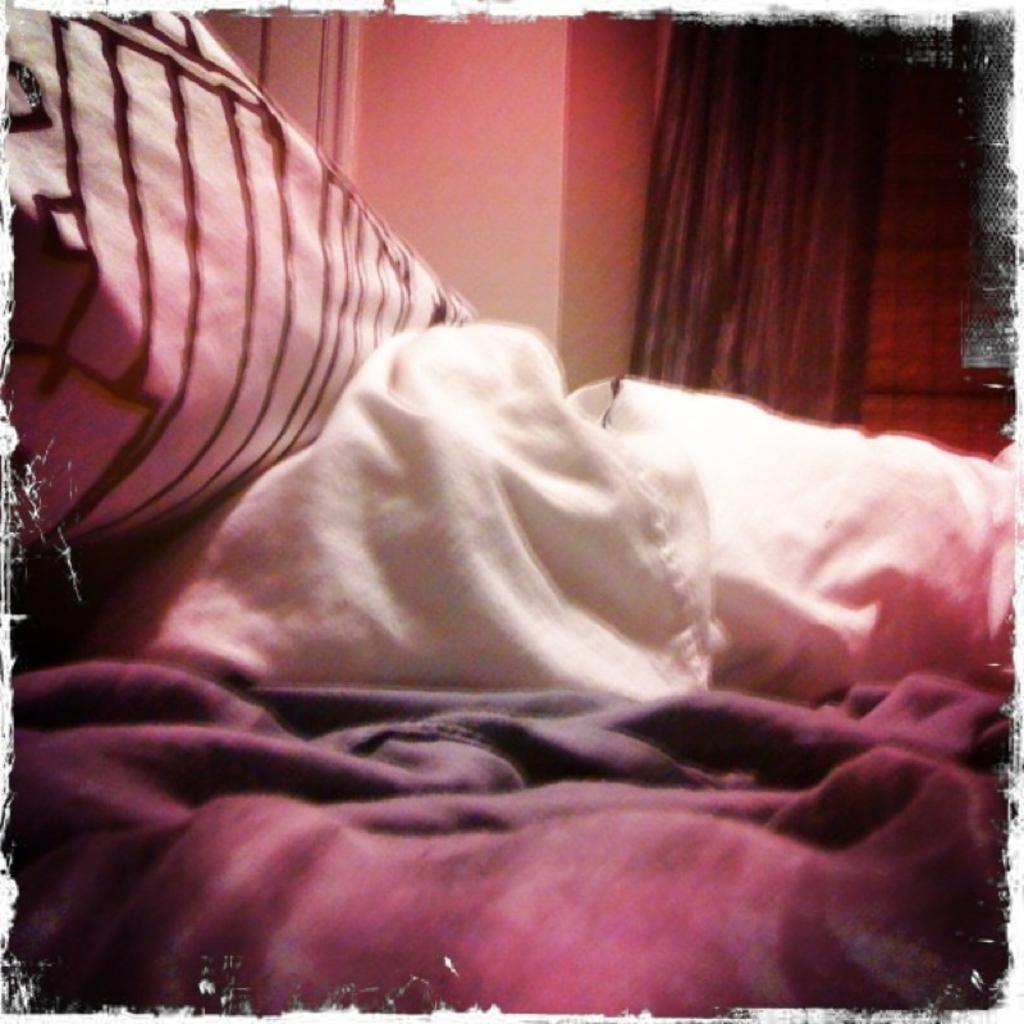What can be seen in the image? There are clothes in the image. What is visible in the background of the image? There is a wall and a curtain in the background of the image. How many men are holding fish in the image? There are no men or fish present in the image. 